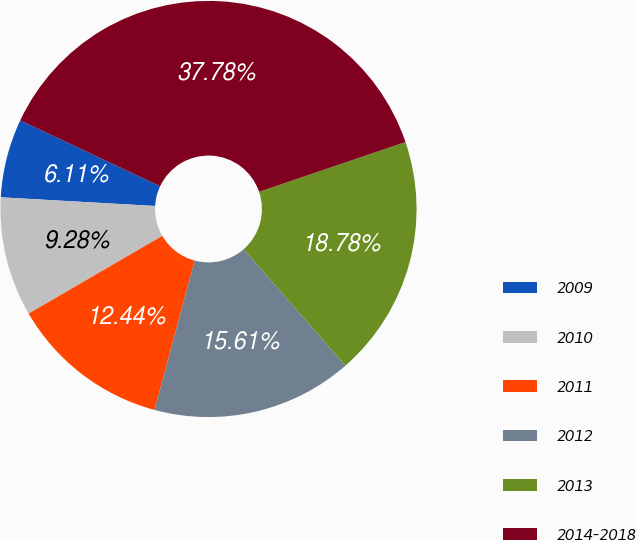Convert chart. <chart><loc_0><loc_0><loc_500><loc_500><pie_chart><fcel>2009<fcel>2010<fcel>2011<fcel>2012<fcel>2013<fcel>2014-2018<nl><fcel>6.11%<fcel>9.28%<fcel>12.44%<fcel>15.61%<fcel>18.78%<fcel>37.78%<nl></chart> 